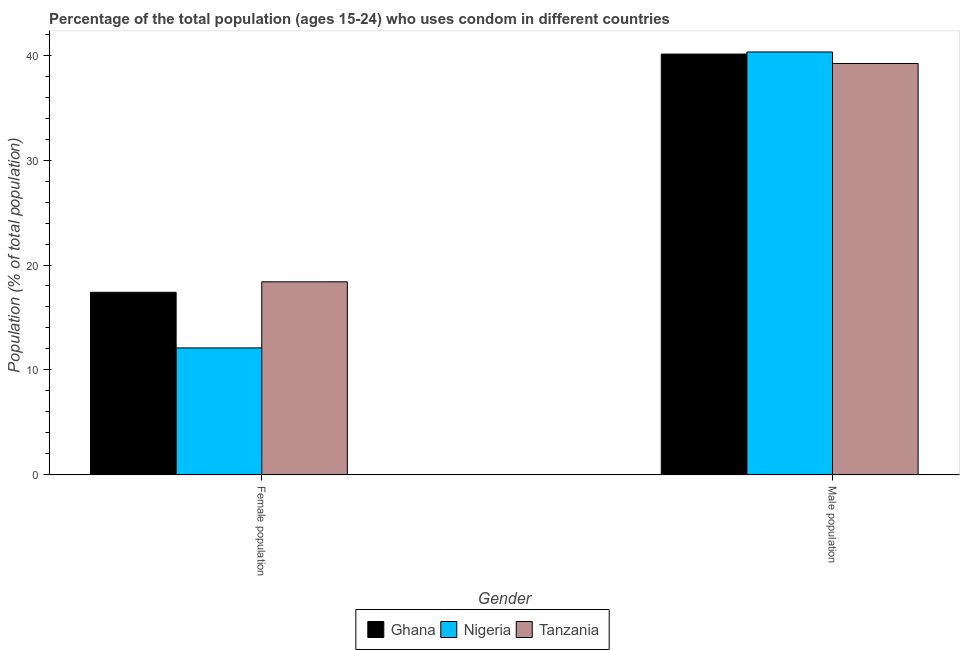Are the number of bars on each tick of the X-axis equal?
Make the answer very short. Yes. How many bars are there on the 1st tick from the left?
Offer a very short reply. 3. How many bars are there on the 2nd tick from the right?
Your answer should be compact. 3. What is the label of the 1st group of bars from the left?
Ensure brevity in your answer.  Female population. Across all countries, what is the maximum male population?
Ensure brevity in your answer.  40.3. Across all countries, what is the minimum male population?
Ensure brevity in your answer.  39.2. In which country was the female population maximum?
Make the answer very short. Tanzania. In which country was the female population minimum?
Offer a very short reply. Nigeria. What is the total female population in the graph?
Give a very brief answer. 47.9. What is the difference between the male population in Nigeria and that in Ghana?
Offer a terse response. 0.2. What is the average male population per country?
Provide a short and direct response. 39.87. What is the difference between the female population and male population in Nigeria?
Offer a terse response. -28.2. In how many countries, is the male population greater than 10 %?
Your answer should be very brief. 3. What is the ratio of the male population in Ghana to that in Nigeria?
Provide a succinct answer. 1. What does the 2nd bar from the left in Female population represents?
Your answer should be very brief. Nigeria. What does the 2nd bar from the right in Male population represents?
Your answer should be very brief. Nigeria. How many bars are there?
Provide a short and direct response. 6. Does the graph contain any zero values?
Your answer should be compact. No. Does the graph contain grids?
Offer a terse response. No. Where does the legend appear in the graph?
Offer a terse response. Bottom center. How many legend labels are there?
Offer a terse response. 3. How are the legend labels stacked?
Your response must be concise. Horizontal. What is the title of the graph?
Provide a succinct answer. Percentage of the total population (ages 15-24) who uses condom in different countries. What is the label or title of the X-axis?
Keep it short and to the point. Gender. What is the label or title of the Y-axis?
Ensure brevity in your answer.  Population (% of total population) . What is the Population (% of total population)  of Nigeria in Female population?
Keep it short and to the point. 12.1. What is the Population (% of total population)  of Tanzania in Female population?
Make the answer very short. 18.4. What is the Population (% of total population)  of Ghana in Male population?
Provide a succinct answer. 40.1. What is the Population (% of total population)  in Nigeria in Male population?
Provide a succinct answer. 40.3. What is the Population (% of total population)  in Tanzania in Male population?
Ensure brevity in your answer.  39.2. Across all Gender, what is the maximum Population (% of total population)  of Ghana?
Your answer should be compact. 40.1. Across all Gender, what is the maximum Population (% of total population)  of Nigeria?
Make the answer very short. 40.3. Across all Gender, what is the maximum Population (% of total population)  in Tanzania?
Your answer should be very brief. 39.2. Across all Gender, what is the minimum Population (% of total population)  of Nigeria?
Your answer should be compact. 12.1. Across all Gender, what is the minimum Population (% of total population)  of Tanzania?
Make the answer very short. 18.4. What is the total Population (% of total population)  in Ghana in the graph?
Your response must be concise. 57.5. What is the total Population (% of total population)  of Nigeria in the graph?
Your answer should be compact. 52.4. What is the total Population (% of total population)  of Tanzania in the graph?
Your answer should be very brief. 57.6. What is the difference between the Population (% of total population)  in Ghana in Female population and that in Male population?
Offer a terse response. -22.7. What is the difference between the Population (% of total population)  of Nigeria in Female population and that in Male population?
Offer a terse response. -28.2. What is the difference between the Population (% of total population)  of Tanzania in Female population and that in Male population?
Your answer should be compact. -20.8. What is the difference between the Population (% of total population)  in Ghana in Female population and the Population (% of total population)  in Nigeria in Male population?
Make the answer very short. -22.9. What is the difference between the Population (% of total population)  in Ghana in Female population and the Population (% of total population)  in Tanzania in Male population?
Offer a very short reply. -21.8. What is the difference between the Population (% of total population)  in Nigeria in Female population and the Population (% of total population)  in Tanzania in Male population?
Your answer should be compact. -27.1. What is the average Population (% of total population)  of Ghana per Gender?
Make the answer very short. 28.75. What is the average Population (% of total population)  in Nigeria per Gender?
Provide a short and direct response. 26.2. What is the average Population (% of total population)  in Tanzania per Gender?
Provide a short and direct response. 28.8. What is the difference between the Population (% of total population)  in Nigeria and Population (% of total population)  in Tanzania in Male population?
Give a very brief answer. 1.1. What is the ratio of the Population (% of total population)  of Ghana in Female population to that in Male population?
Ensure brevity in your answer.  0.43. What is the ratio of the Population (% of total population)  in Nigeria in Female population to that in Male population?
Give a very brief answer. 0.3. What is the ratio of the Population (% of total population)  of Tanzania in Female population to that in Male population?
Offer a very short reply. 0.47. What is the difference between the highest and the second highest Population (% of total population)  of Ghana?
Your answer should be very brief. 22.7. What is the difference between the highest and the second highest Population (% of total population)  of Nigeria?
Provide a short and direct response. 28.2. What is the difference between the highest and the second highest Population (% of total population)  in Tanzania?
Your answer should be compact. 20.8. What is the difference between the highest and the lowest Population (% of total population)  of Ghana?
Ensure brevity in your answer.  22.7. What is the difference between the highest and the lowest Population (% of total population)  in Nigeria?
Give a very brief answer. 28.2. What is the difference between the highest and the lowest Population (% of total population)  in Tanzania?
Offer a terse response. 20.8. 